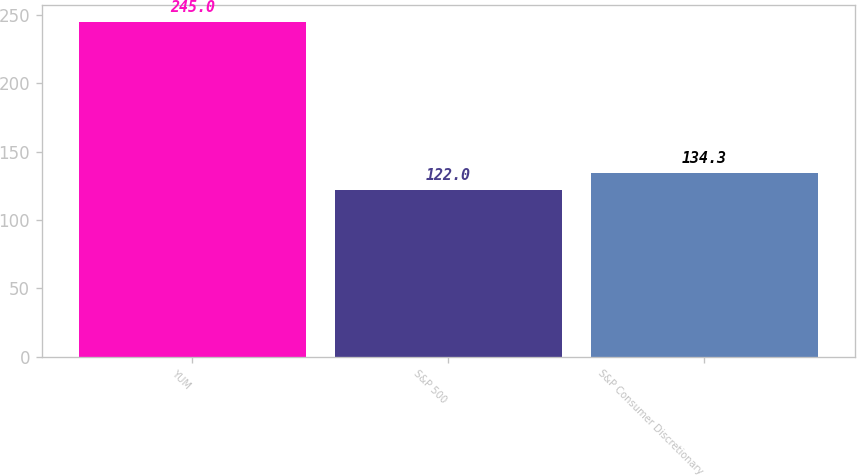Convert chart to OTSL. <chart><loc_0><loc_0><loc_500><loc_500><bar_chart><fcel>YUM<fcel>S&P 500<fcel>S&P Consumer Discretionary<nl><fcel>245<fcel>122<fcel>134.3<nl></chart> 